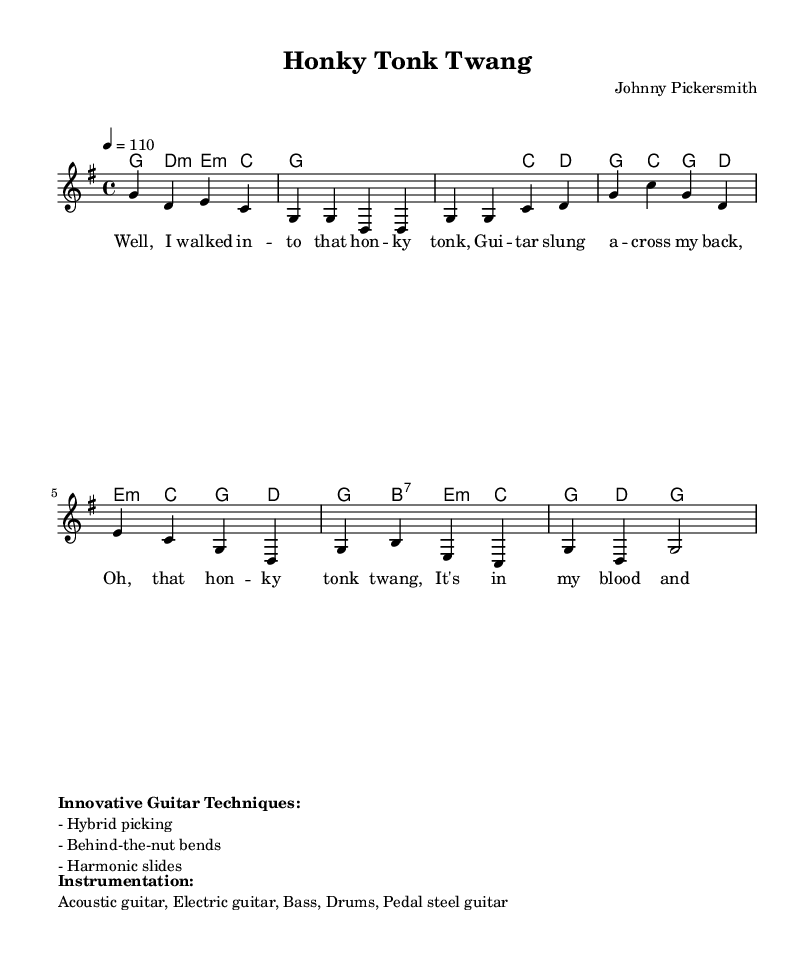What is the key signature of this music? The key signature is G major, which has one sharp (F#) indicated. This can be identified by looking at the beginning of the staff where the key signature is notated.
Answer: G major What is the time signature of this piece? The time signature is 4/4, shown at the beginning of the staff. This indicates that there are four beats in each measure.
Answer: 4/4 What is the tempo marking for this piece? The tempo marking is 4 = 110, which specifies the beats per minute for the piece. The '4' represents quarter notes, and '110' is the tempo speed, meaning 110 beats per minute.
Answer: 110 How many sections are there in the music? There are four sections: Intro, Verse, Chorus, and Solo. This can be deduced from the structure presented in the sheet music which labels each part sequentially.
Answer: Four What innovative guitar techniques are mentioned? The techniques mentioned are hybrid picking, behind-the-nut bends, and harmonic slides. These are noted in the marked section of the sheet music after the melody.
Answer: Hybrid picking, behind-the-nut bends, harmonic slides What types of instruments are used in this piece? The instruments used are acoustic guitar, electric guitar, bass, drums, and pedal steel guitar, as listed in the instrumentation section of the sheet music.
Answer: Acoustic guitar, electric guitar, bass, drums, pedal steel guitar 